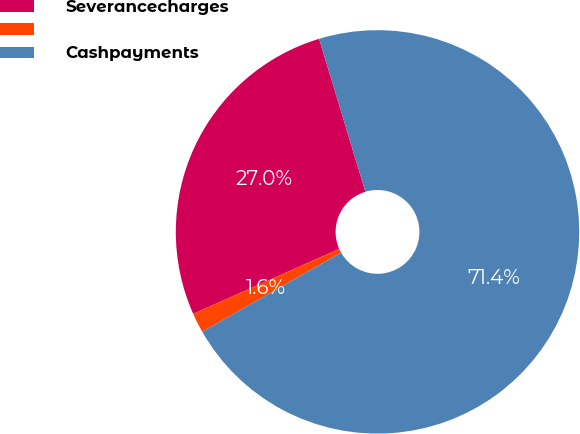Convert chart. <chart><loc_0><loc_0><loc_500><loc_500><pie_chart><fcel>Severancecharges<fcel>Unnamed: 1<fcel>Cashpayments<nl><fcel>26.98%<fcel>1.59%<fcel>71.43%<nl></chart> 